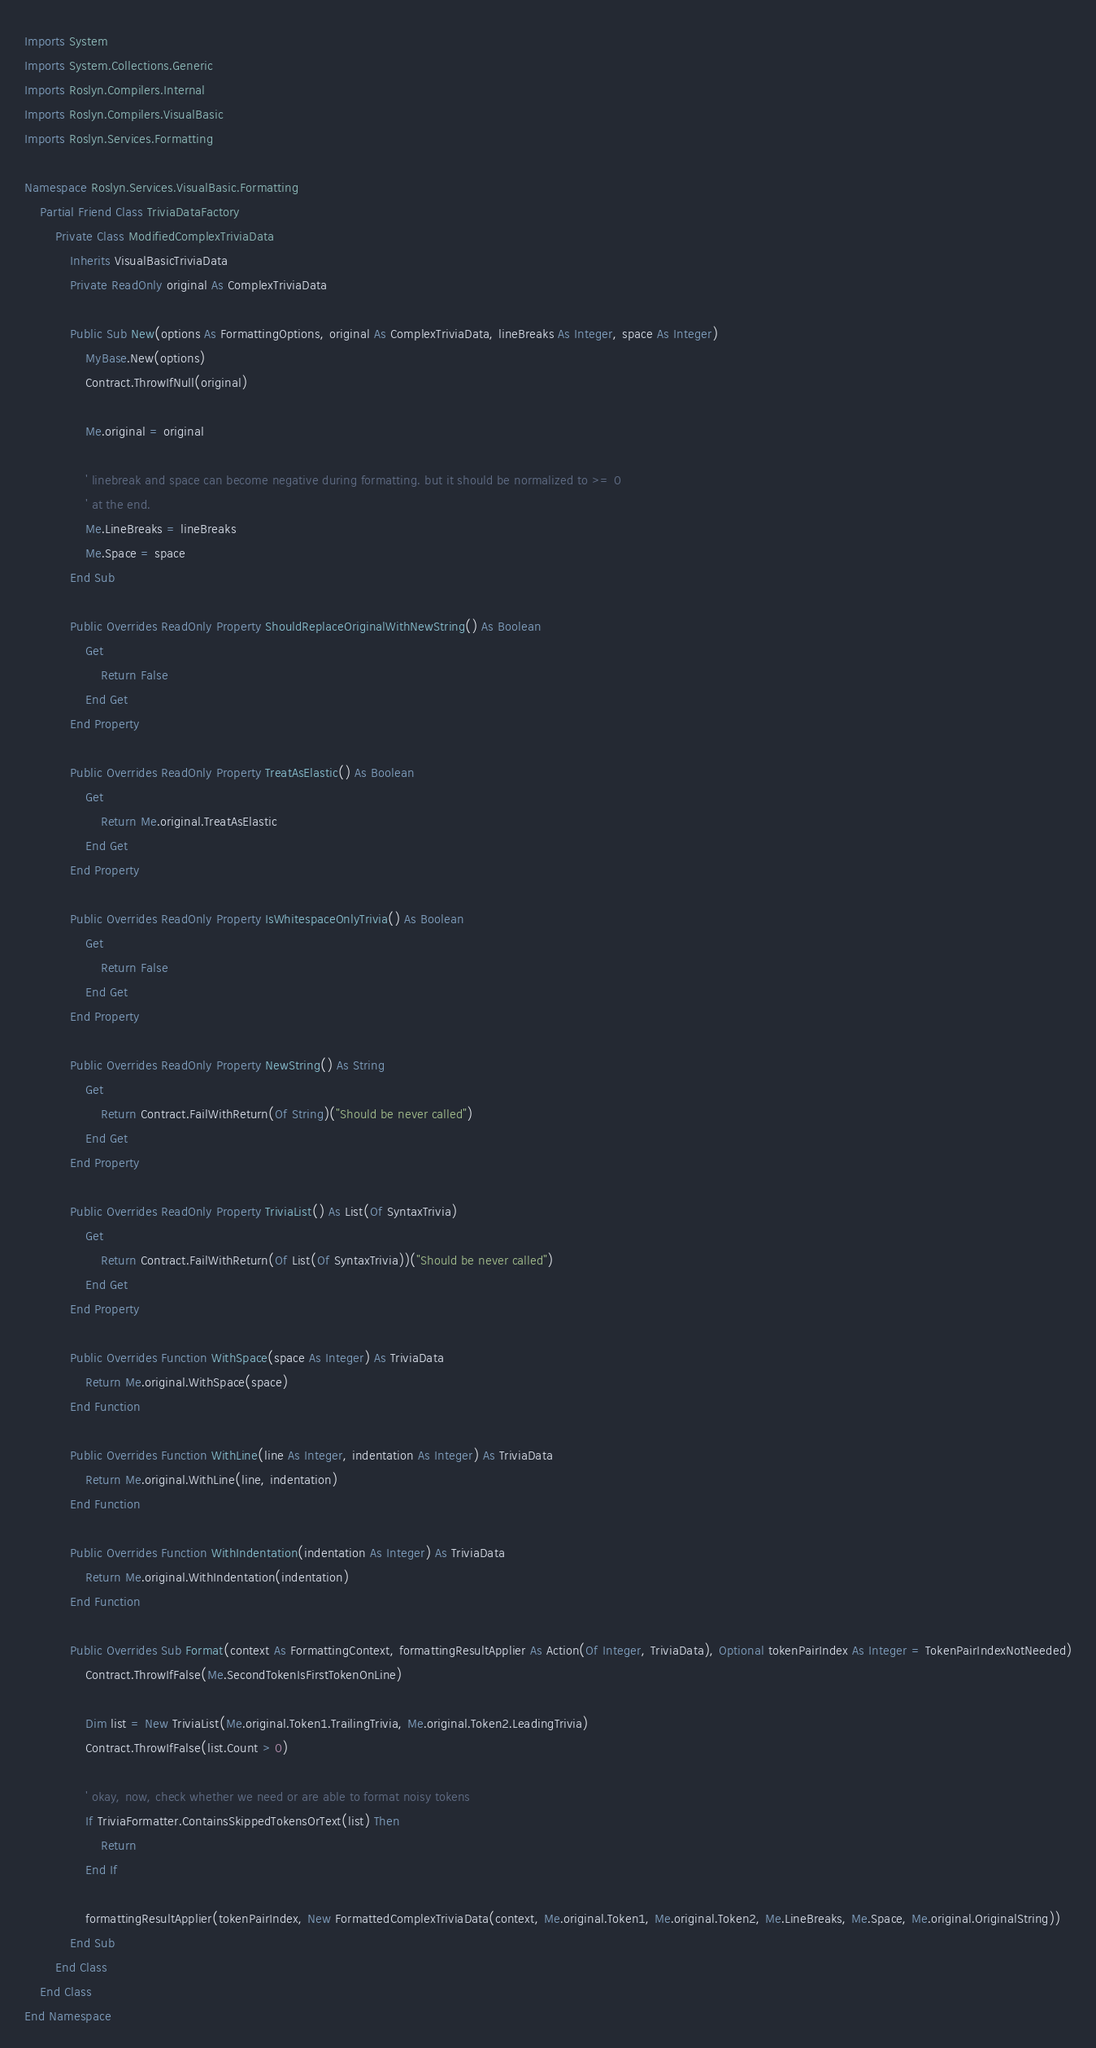Convert code to text. <code><loc_0><loc_0><loc_500><loc_500><_VisualBasic_>Imports System
Imports System.Collections.Generic
Imports Roslyn.Compilers.Internal
Imports Roslyn.Compilers.VisualBasic
Imports Roslyn.Services.Formatting

Namespace Roslyn.Services.VisualBasic.Formatting
    Partial Friend Class TriviaDataFactory
        Private Class ModifiedComplexTriviaData
            Inherits VisualBasicTriviaData
            Private ReadOnly original As ComplexTriviaData

            Public Sub New(options As FormattingOptions, original As ComplexTriviaData, lineBreaks As Integer, space As Integer)
                MyBase.New(options)
                Contract.ThrowIfNull(original)

                Me.original = original

                ' linebreak and space can become negative during formatting. but it should be normalized to >= 0
                ' at the end.
                Me.LineBreaks = lineBreaks
                Me.Space = space
            End Sub

            Public Overrides ReadOnly Property ShouldReplaceOriginalWithNewString() As Boolean
                Get
                    Return False
                End Get
            End Property

            Public Overrides ReadOnly Property TreatAsElastic() As Boolean
                Get
                    Return Me.original.TreatAsElastic
                End Get
            End Property

            Public Overrides ReadOnly Property IsWhitespaceOnlyTrivia() As Boolean
                Get
                    Return False
                End Get
            End Property

            Public Overrides ReadOnly Property NewString() As String
                Get
                    Return Contract.FailWithReturn(Of String)("Should be never called")
                End Get
            End Property

            Public Overrides ReadOnly Property TriviaList() As List(Of SyntaxTrivia)
                Get
                    Return Contract.FailWithReturn(Of List(Of SyntaxTrivia))("Should be never called")
                End Get
            End Property

            Public Overrides Function WithSpace(space As Integer) As TriviaData
                Return Me.original.WithSpace(space)
            End Function

            Public Overrides Function WithLine(line As Integer, indentation As Integer) As TriviaData
                Return Me.original.WithLine(line, indentation)
            End Function

            Public Overrides Function WithIndentation(indentation As Integer) As TriviaData
                Return Me.original.WithIndentation(indentation)
            End Function

            Public Overrides Sub Format(context As FormattingContext, formattingResultApplier As Action(Of Integer, TriviaData), Optional tokenPairIndex As Integer = TokenPairIndexNotNeeded)
                Contract.ThrowIfFalse(Me.SecondTokenIsFirstTokenOnLine)

                Dim list = New TriviaList(Me.original.Token1.TrailingTrivia, Me.original.Token2.LeadingTrivia)
                Contract.ThrowIfFalse(list.Count > 0)

                ' okay, now, check whether we need or are able to format noisy tokens
                If TriviaFormatter.ContainsSkippedTokensOrText(list) Then
                    Return
                End If

                formattingResultApplier(tokenPairIndex, New FormattedComplexTriviaData(context, Me.original.Token1, Me.original.Token2, Me.LineBreaks, Me.Space, Me.original.OriginalString))
            End Sub
        End Class
    End Class
End Namespace</code> 